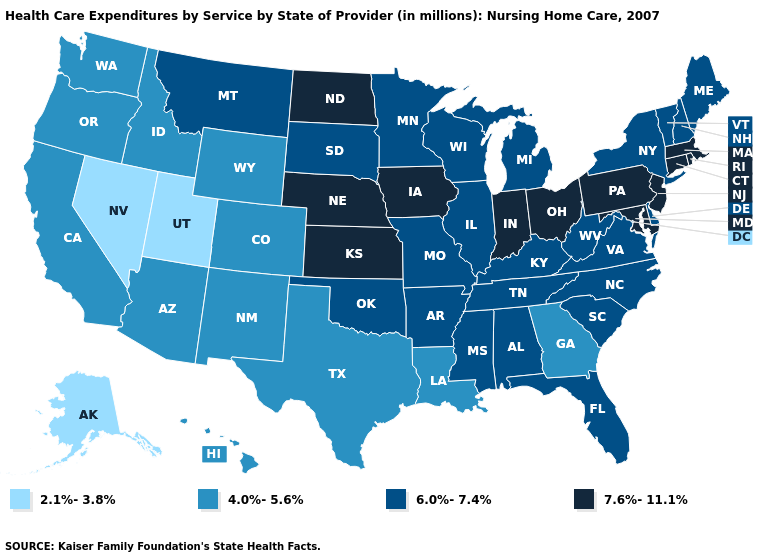Does the first symbol in the legend represent the smallest category?
Give a very brief answer. Yes. Does the first symbol in the legend represent the smallest category?
Be succinct. Yes. What is the value of Maryland?
Answer briefly. 7.6%-11.1%. What is the highest value in the West ?
Be succinct. 6.0%-7.4%. Does New Hampshire have the highest value in the Northeast?
Short answer required. No. Does the first symbol in the legend represent the smallest category?
Be succinct. Yes. What is the lowest value in the MidWest?
Short answer required. 6.0%-7.4%. Which states have the highest value in the USA?
Quick response, please. Connecticut, Indiana, Iowa, Kansas, Maryland, Massachusetts, Nebraska, New Jersey, North Dakota, Ohio, Pennsylvania, Rhode Island. What is the value of Nebraska?
Answer briefly. 7.6%-11.1%. Does Oklahoma have a higher value than North Dakota?
Concise answer only. No. What is the highest value in states that border South Dakota?
Quick response, please. 7.6%-11.1%. Name the states that have a value in the range 2.1%-3.8%?
Concise answer only. Alaska, Nevada, Utah. Does Nebraska have a higher value than Indiana?
Answer briefly. No. Name the states that have a value in the range 4.0%-5.6%?
Short answer required. Arizona, California, Colorado, Georgia, Hawaii, Idaho, Louisiana, New Mexico, Oregon, Texas, Washington, Wyoming. Does Utah have the lowest value in the USA?
Be succinct. Yes. 